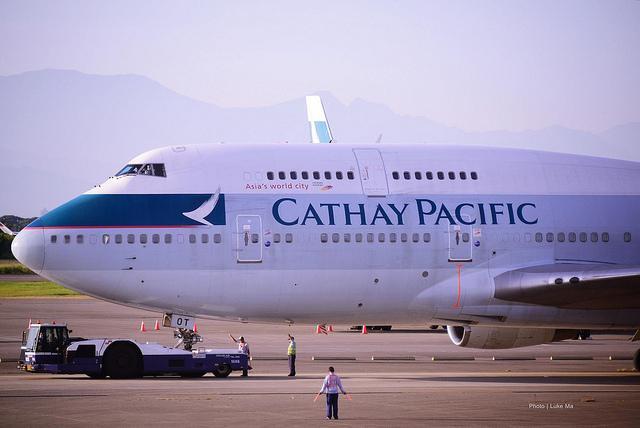How many trucks are in the picture?
Give a very brief answer. 2. How many airplanes are visible?
Give a very brief answer. 1. 